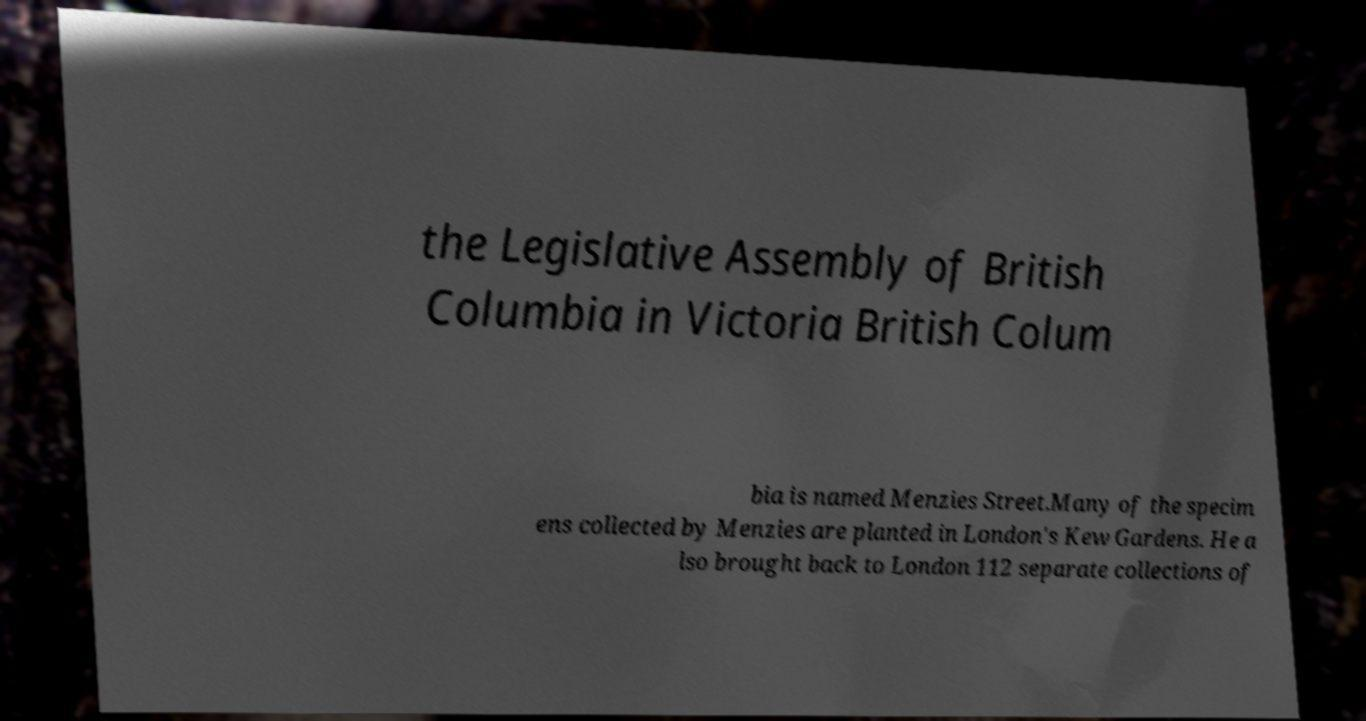There's text embedded in this image that I need extracted. Can you transcribe it verbatim? the Legislative Assembly of British Columbia in Victoria British Colum bia is named Menzies Street.Many of the specim ens collected by Menzies are planted in London's Kew Gardens. He a lso brought back to London 112 separate collections of 